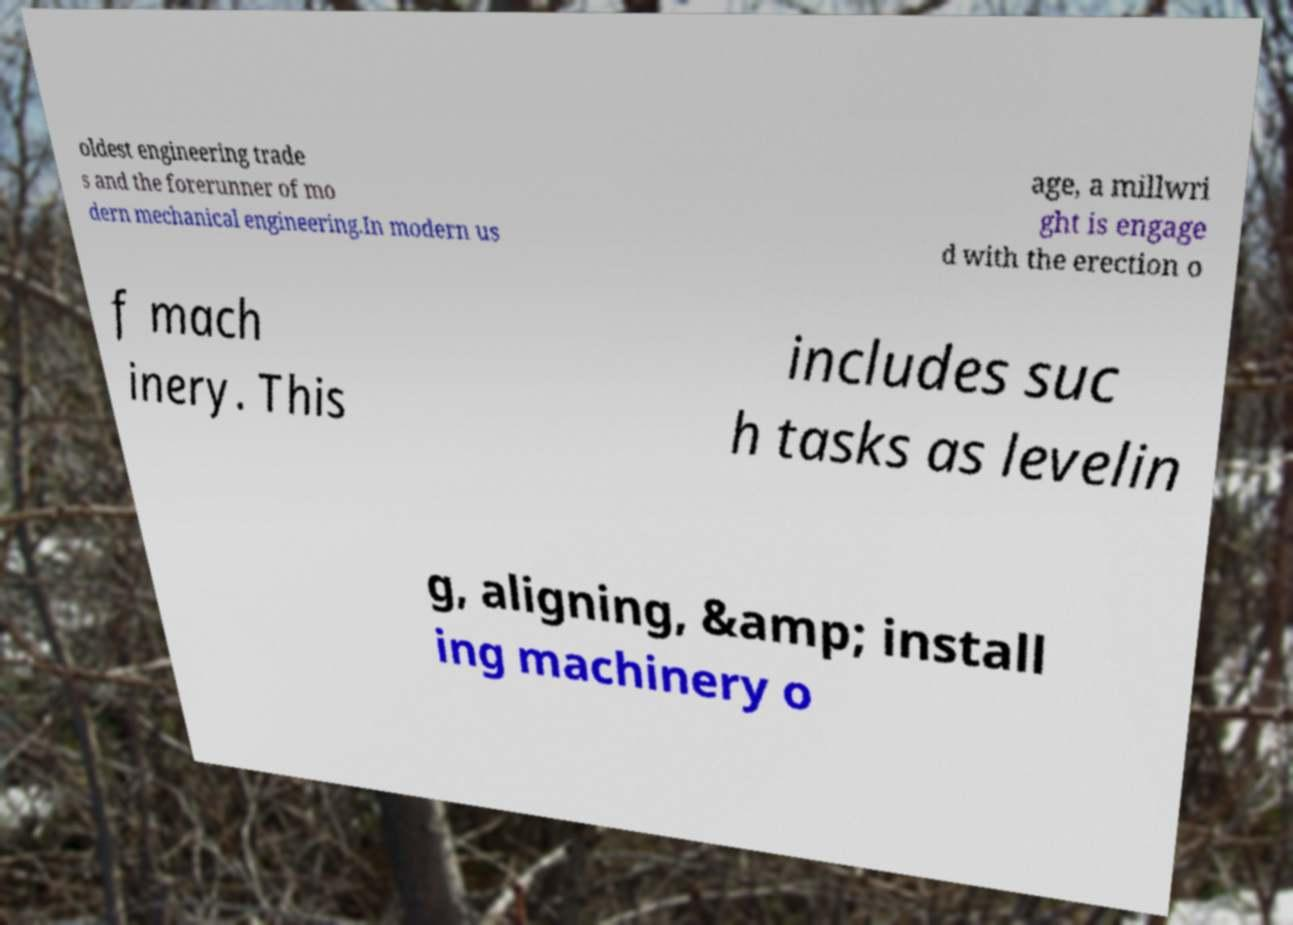Can you accurately transcribe the text from the provided image for me? oldest engineering trade s and the forerunner of mo dern mechanical engineering.In modern us age, a millwri ght is engage d with the erection o f mach inery. This includes suc h tasks as levelin g, aligning, &amp; install ing machinery o 